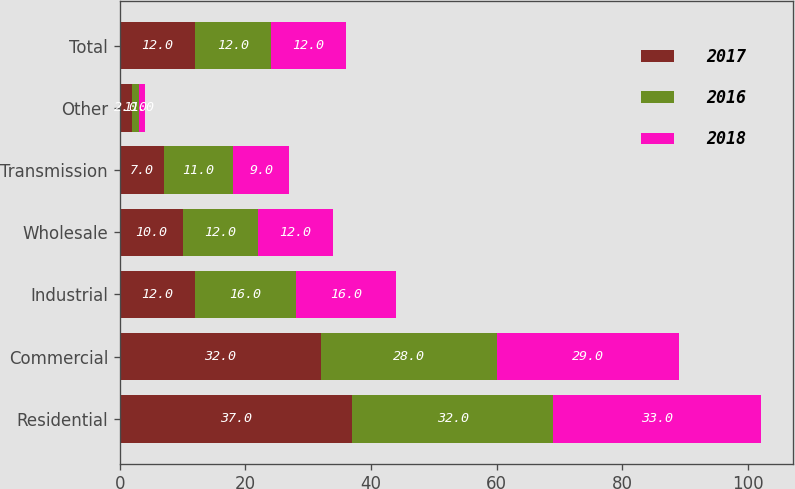Convert chart to OTSL. <chart><loc_0><loc_0><loc_500><loc_500><stacked_bar_chart><ecel><fcel>Residential<fcel>Commercial<fcel>Industrial<fcel>Wholesale<fcel>Transmission<fcel>Other<fcel>Total<nl><fcel>2017<fcel>37<fcel>32<fcel>12<fcel>10<fcel>7<fcel>2<fcel>12<nl><fcel>2016<fcel>32<fcel>28<fcel>16<fcel>12<fcel>11<fcel>1<fcel>12<nl><fcel>2018<fcel>33<fcel>29<fcel>16<fcel>12<fcel>9<fcel>1<fcel>12<nl></chart> 